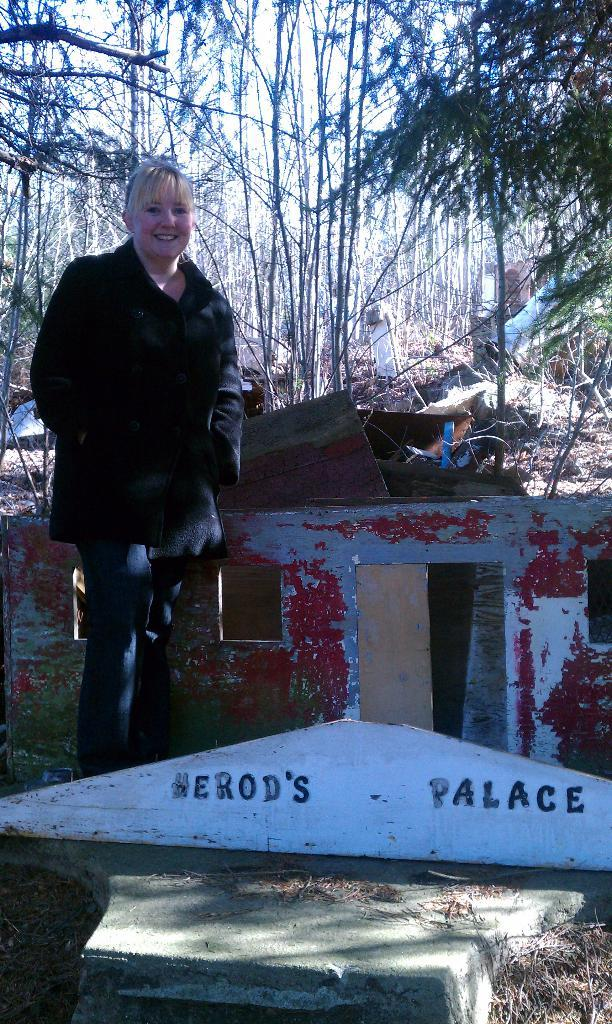What is written or depicted on an object in the image? There is text on an object in the image. Can you describe the woman in the image? There is a woman standing in the image, and she is smiling. What type of natural environment is visible in the image? There are trees in the image, indicating a natural setting. What else can be seen in the image besides the woman and trees? There are other objects in the image. What type of fruit is the woman kicking in the image? There is no fruit present in the image, nor is the woman kicking anything. 